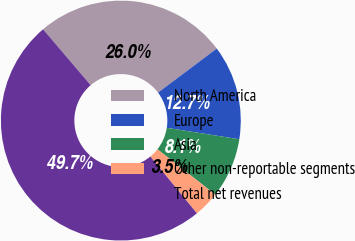<chart> <loc_0><loc_0><loc_500><loc_500><pie_chart><fcel>North America<fcel>Europe<fcel>Asia<fcel>Other non-reportable segments<fcel>Total net revenues<nl><fcel>25.98%<fcel>12.74%<fcel>8.1%<fcel>3.48%<fcel>49.7%<nl></chart> 